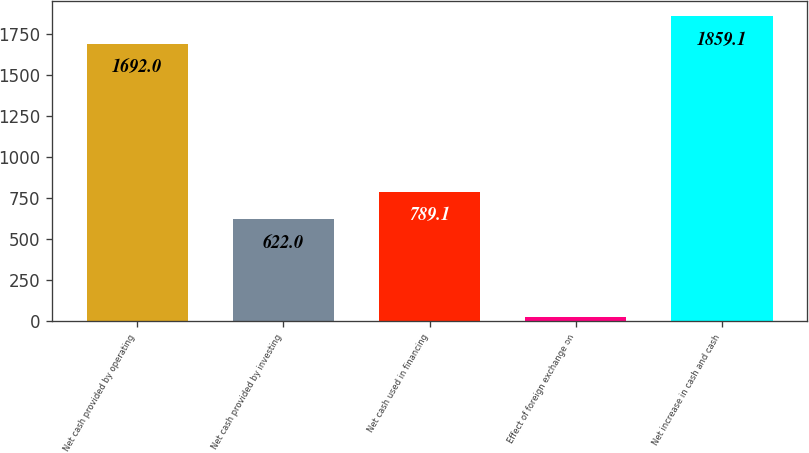Convert chart. <chart><loc_0><loc_0><loc_500><loc_500><bar_chart><fcel>Net cash provided by operating<fcel>Net cash provided by investing<fcel>Net cash used in financing<fcel>Effect of foreign exchange on<fcel>Net increase in cash and cash<nl><fcel>1692<fcel>622<fcel>789.1<fcel>22<fcel>1859.1<nl></chart> 